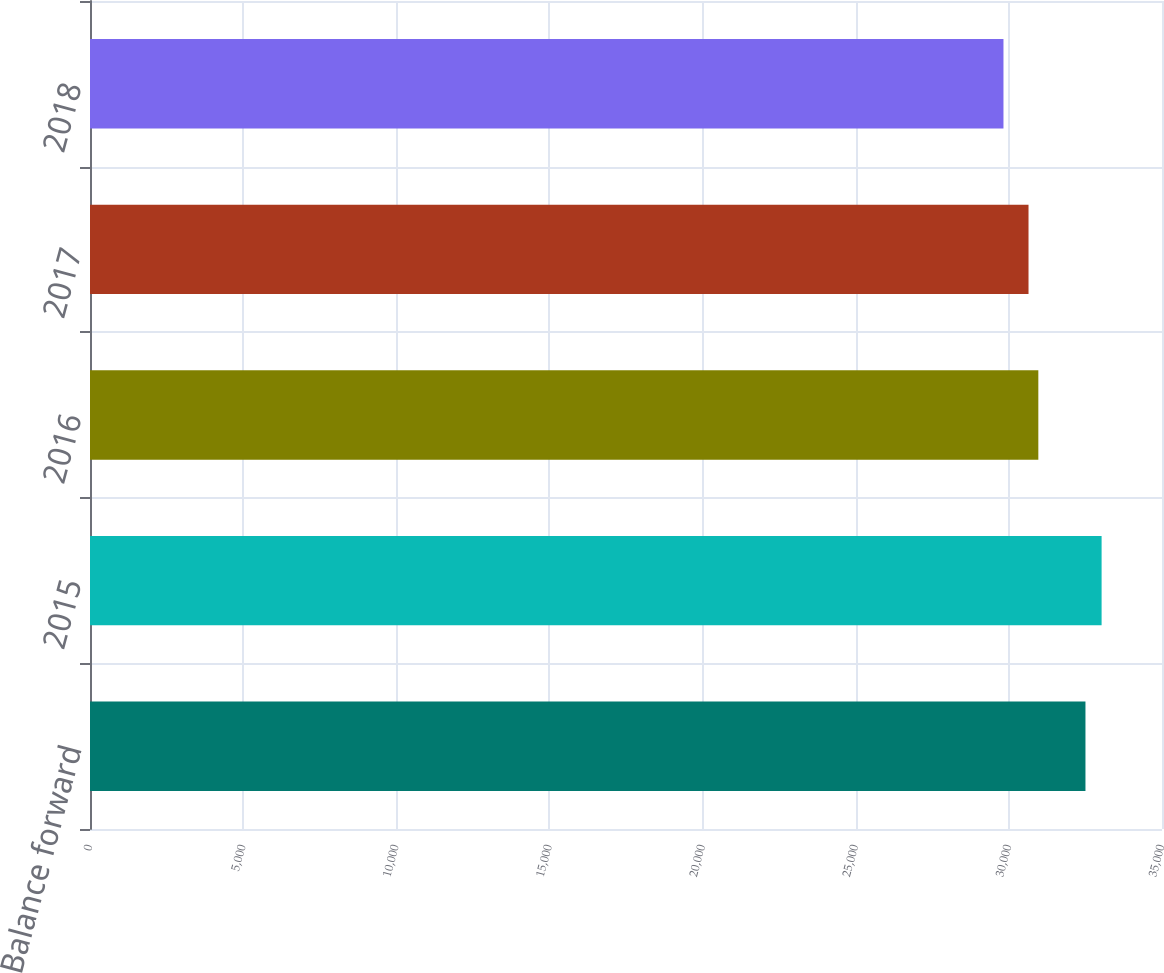<chart> <loc_0><loc_0><loc_500><loc_500><bar_chart><fcel>Balance forward<fcel>2015<fcel>2016<fcel>2017<fcel>2018<nl><fcel>32501<fcel>33028<fcel>30962.4<fcel>30642<fcel>29824<nl></chart> 